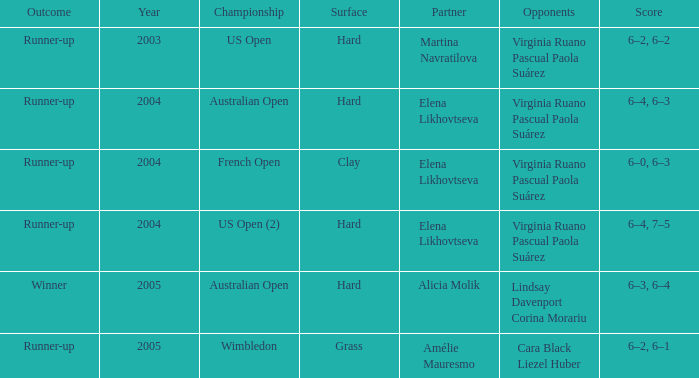When Australian open is the championship what is the lowest year? 2004.0. 